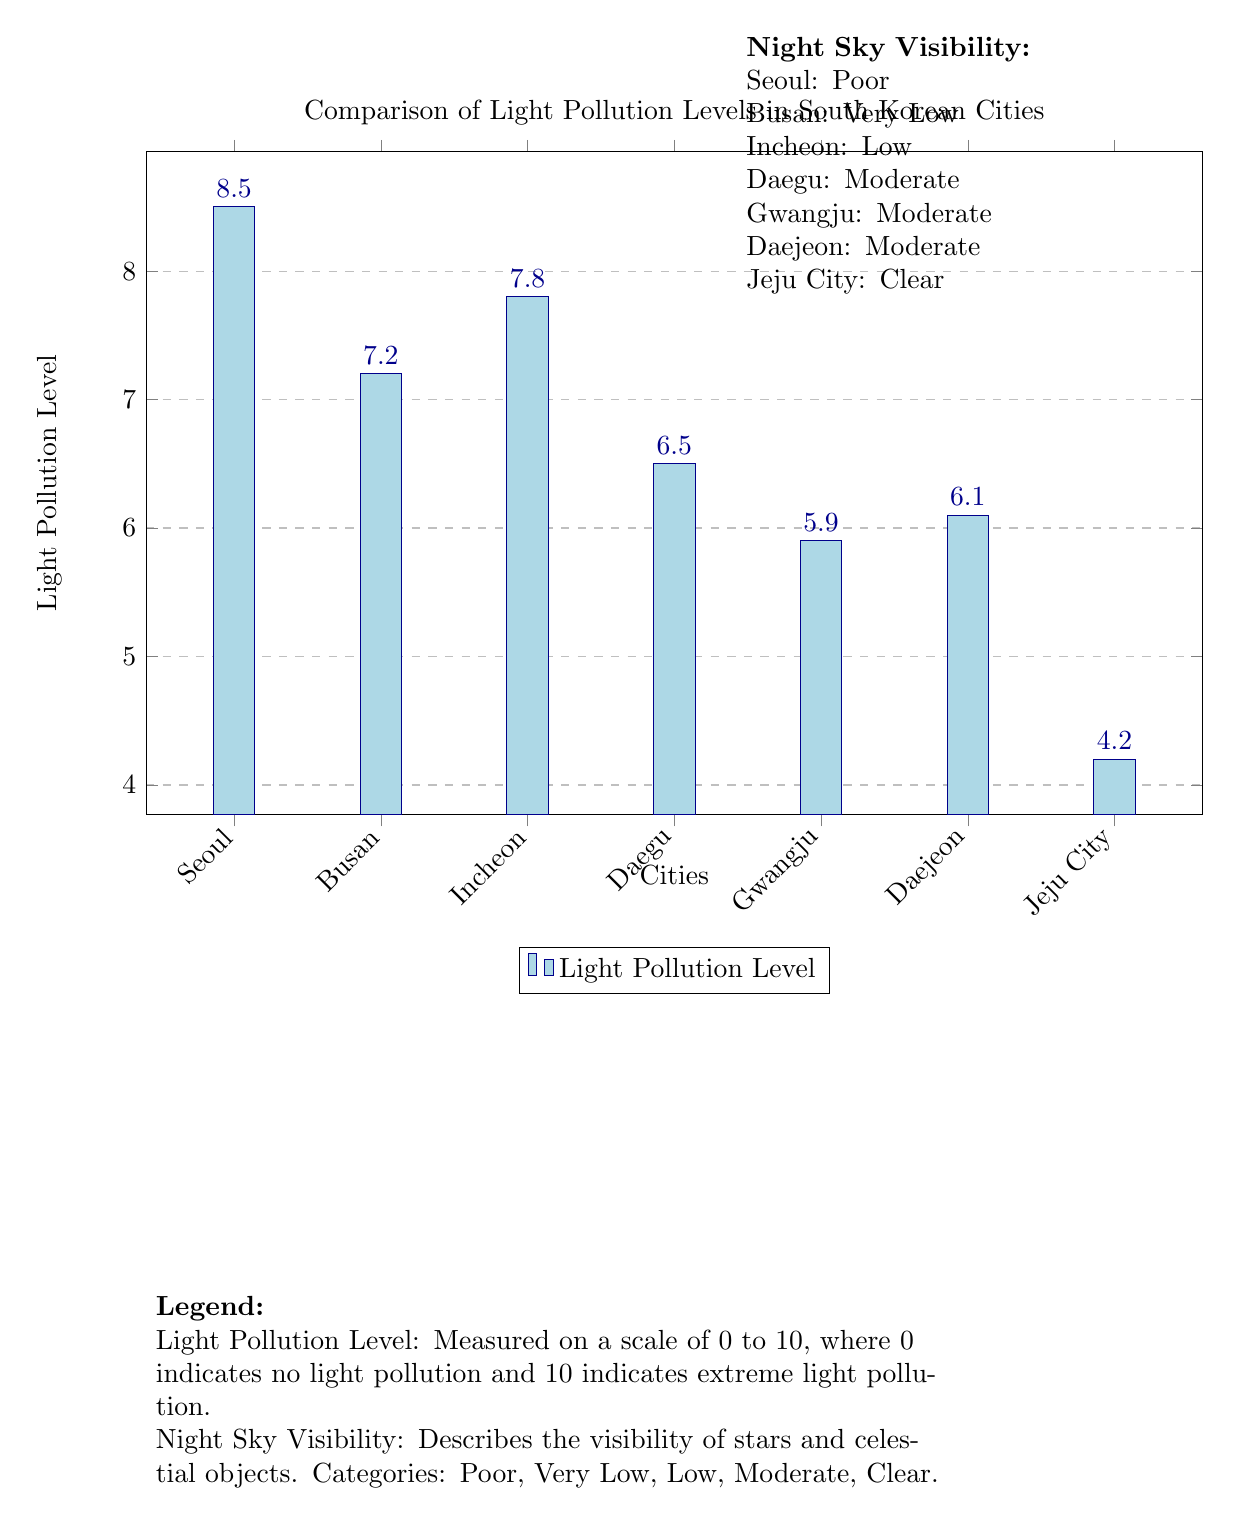What is the light pollution level in Jeju City? The diagram shows that Jeju City has a light pollution level of 4.2, indicated by the bar height corresponding to this city on the chart.
Answer: 4.2 Which city has the highest light pollution level? By comparing the bar heights in the diagram, Seoul has the highest light pollution level at 8.5, as it is the tallest bar in the graph.
Answer: Seoul What is the night sky visibility rating for Busan? The description next to the diagram states that Busan’s night sky visibility is rated as "Very Low," which is clearly mentioned in the visibility section.
Answer: Very Low How many cities are compared in this diagram? The x-axis lists a total of seven cities (Seoul, Busan, Incheon, Daegu, Gwangju, Daejeon, Jeju City), confirming the total count of cities included in the comparison.
Answer: Seven What is the light pollution level of Gwangju? The graph indicates that Gwangju has a light pollution level of 5.9, which can be read directly from the bar corresponding to Gwangju.
Answer: 5.9 Which city has 'Moderate' night sky visibility? According to the visibility descriptions, Daegu, Gwangju, and Daejeon all have a night sky visibility rating of "Moderate," as per the stated categories next to the bar graph.
Answer: Daegu, Gwangju, Daejeon What is the scale range for measuring light pollution levels? The diagram specifies a scale for light pollution levels ranging from 0 to 10, where 0 represents no pollution and 10 indicates extreme pollution. This information is also highlighted in the legend.
Answer: 0 to 10 What color represents the highest level of light pollution in the diagram? The highest light pollution level is represented by the color dark blue, which corresponds to the light pollution levels shown in the bar graph for Seoul.
Answer: Dark blue 